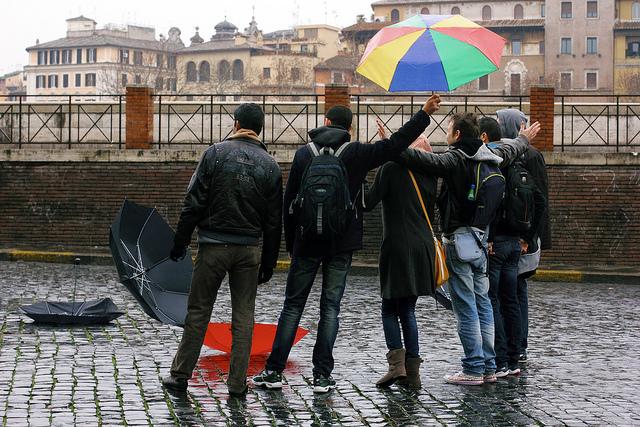How many umbrellas are there?
Short answer required. 4. How many umbrellas are in the picture?
Be succinct. 4. How many people are in the picture?
Be succinct. 6. What color is the man with the black boots wearing?
Answer briefly. Black. How many colors are in the umbrella being held over the group's heads?
Be succinct. 4. 